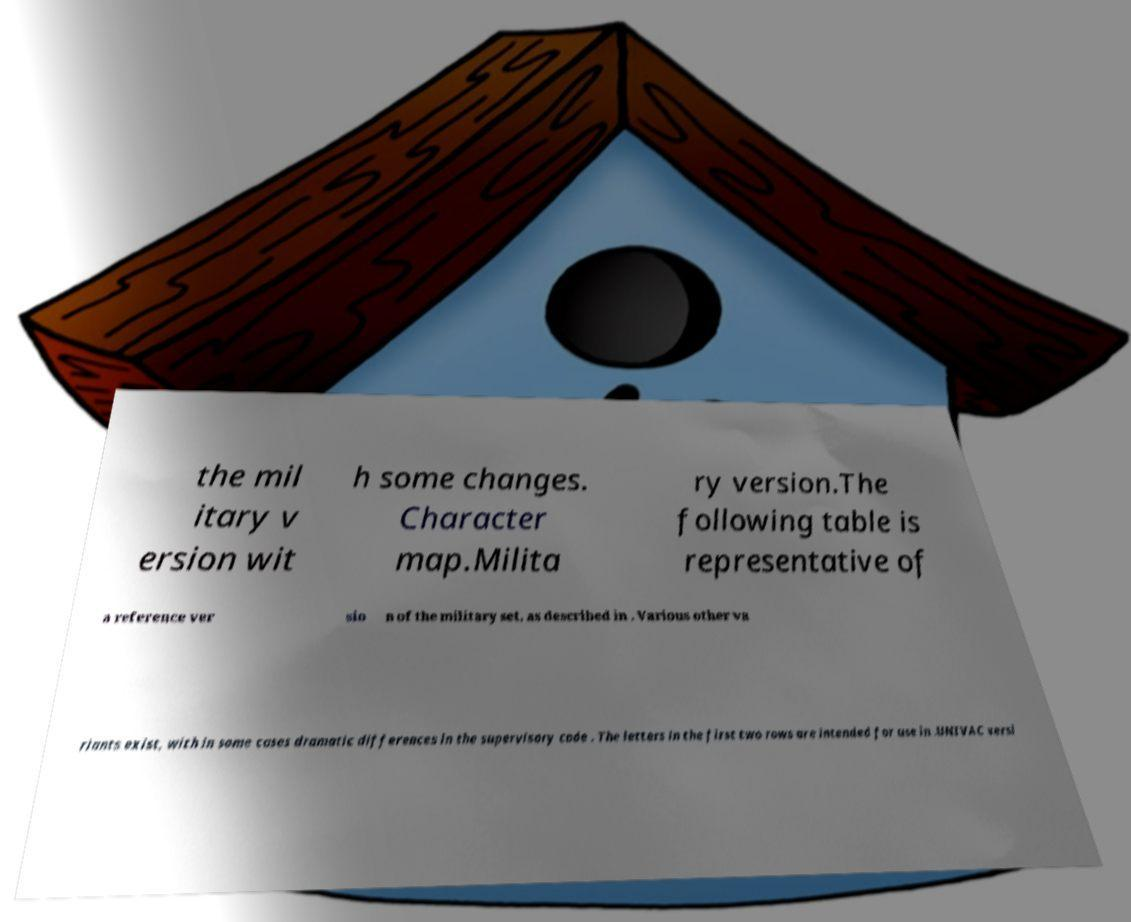Could you extract and type out the text from this image? the mil itary v ersion wit h some changes. Character map.Milita ry version.The following table is representative of a reference ver sio n of the military set, as described in . Various other va riants exist, with in some cases dramatic differences in the supervisory code . The letters in the first two rows are intended for use in .UNIVAC versi 